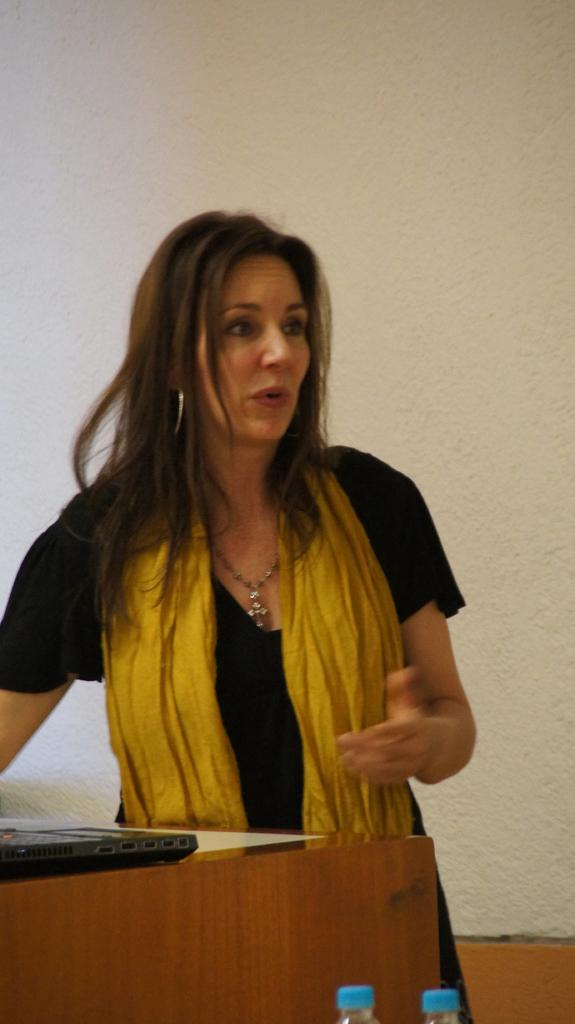What is the main subject of the image? There is a woman standing in the center of the image. What is in front of the woman? There is a wooden stand in front of the woman. What is placed on the wooden stand? A laptop is placed on the wooden stand. What can be seen at the bottom of the image? There are two water bottles at the bottom of the image. What is visible in the background of the image? There is a wall visible in the background. What type of tin is being used to store the woman's desire in the image? There is no tin or reference to desire present in the image. 